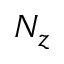<formula> <loc_0><loc_0><loc_500><loc_500>N _ { z }</formula> 